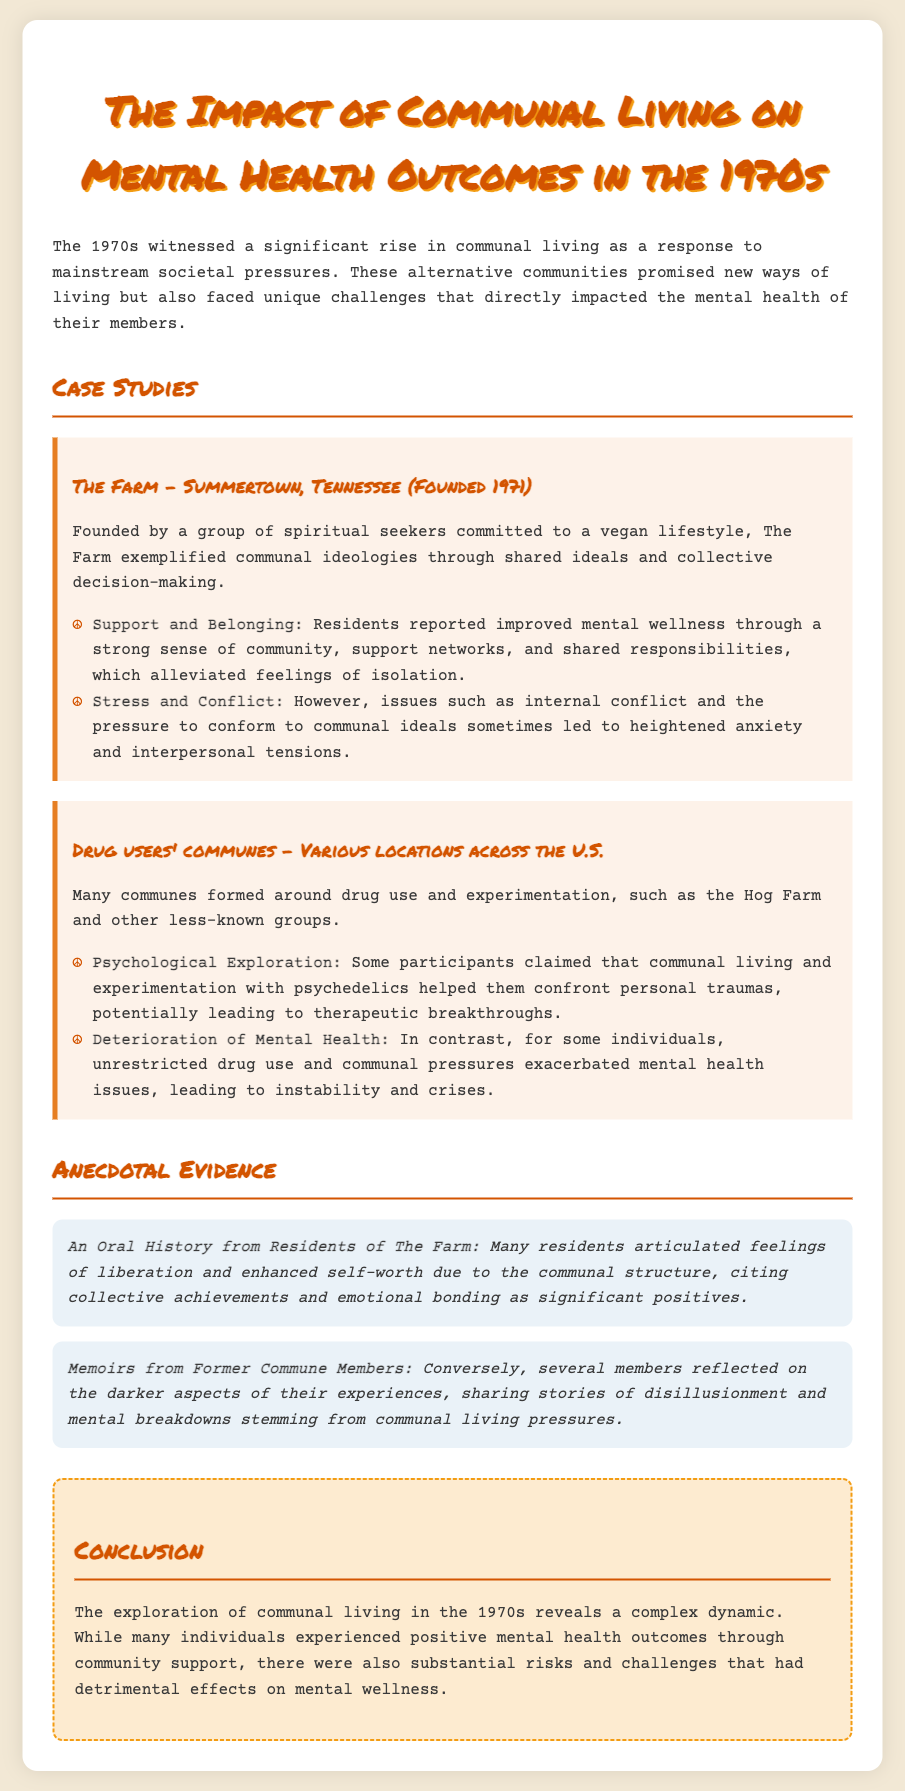What is the title of the document? The title is provided at the beginning of the memo, which summarizes the main topic discussed.
Answer: The Impact of Communal Living on Mental Health Outcomes in the 1970s When was The Farm founded? The founding year of The Farm is mentioned in the case study section regarding its background.
Answer: 1971 What type of lifestyle did residents of The Farm follow? The specific lifestyle choice is detailed in the case study describing the ideologies of The Farm.
Answer: Vegan Which commune is associated with drug use and experimentation? The document discusses various locations and identifies communes primarily focused on drug culture.
Answer: Hog Farm What effect did communal living have on mental wellness in The Farm? The document outlines both positive and negative mental health outcomes for residents, specifically in terms of support and belonging.
Answer: Improved mental wellness What was a reported negative impact of drug users' communes? The text highlights the adverse effects associated with unrestricted drug use among commune members.
Answer: Deterioration of Mental Health What type of evidence is included in the document regarding former residents? The anecdotal evidence provides insights from individuals who lived in these communal spaces reflecting on their experiences.
Answer: Oral History How does the conclusion summarize the outcomes of communal living in the 1970s? The conclusion addresses the complexity of mental health outcomes experienced by individuals, balancing positives and negatives.
Answer: Complex dynamic 